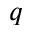Convert formula to latex. <formula><loc_0><loc_0><loc_500><loc_500>q</formula> 